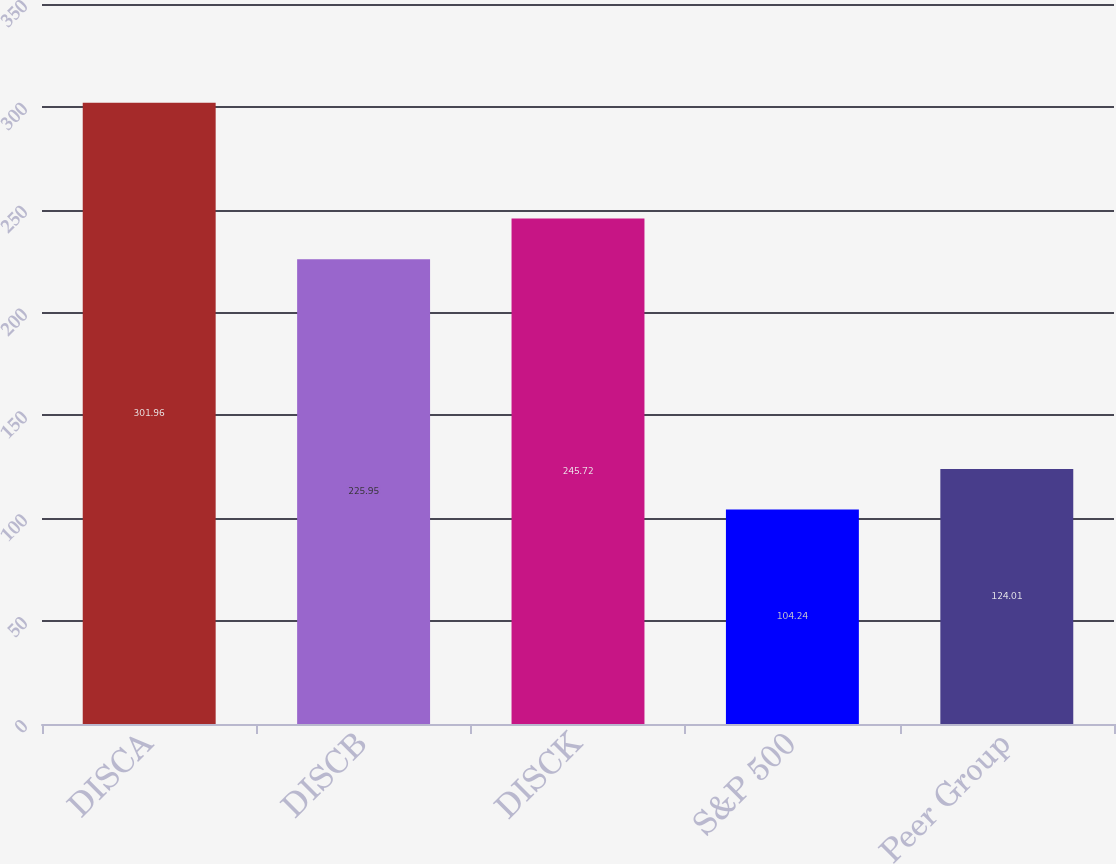Convert chart to OTSL. <chart><loc_0><loc_0><loc_500><loc_500><bar_chart><fcel>DISCA<fcel>DISCB<fcel>DISCK<fcel>S&P 500<fcel>Peer Group<nl><fcel>301.96<fcel>225.95<fcel>245.72<fcel>104.24<fcel>124.01<nl></chart> 